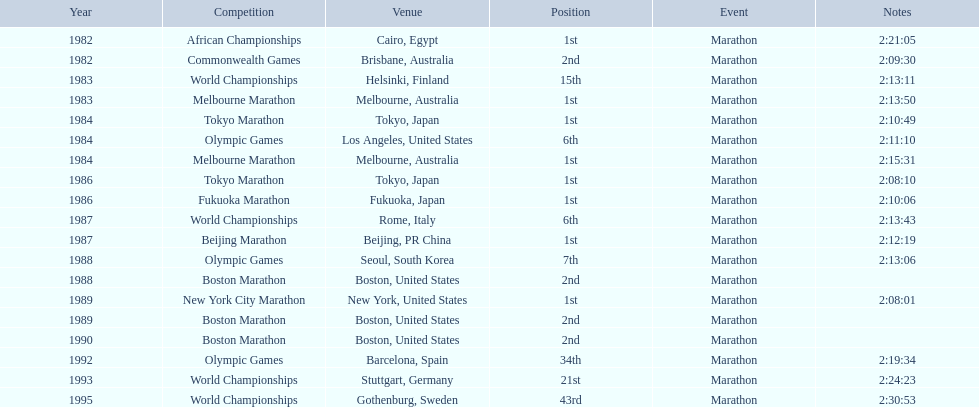In which marathon did juma ikangaa achieve his first victory? 1982 African Championships. 